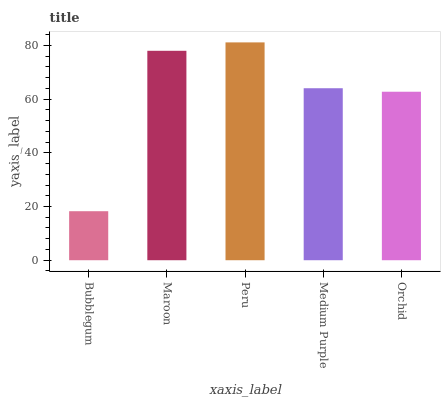Is Bubblegum the minimum?
Answer yes or no. Yes. Is Peru the maximum?
Answer yes or no. Yes. Is Maroon the minimum?
Answer yes or no. No. Is Maroon the maximum?
Answer yes or no. No. Is Maroon greater than Bubblegum?
Answer yes or no. Yes. Is Bubblegum less than Maroon?
Answer yes or no. Yes. Is Bubblegum greater than Maroon?
Answer yes or no. No. Is Maroon less than Bubblegum?
Answer yes or no. No. Is Medium Purple the high median?
Answer yes or no. Yes. Is Medium Purple the low median?
Answer yes or no. Yes. Is Orchid the high median?
Answer yes or no. No. Is Maroon the low median?
Answer yes or no. No. 